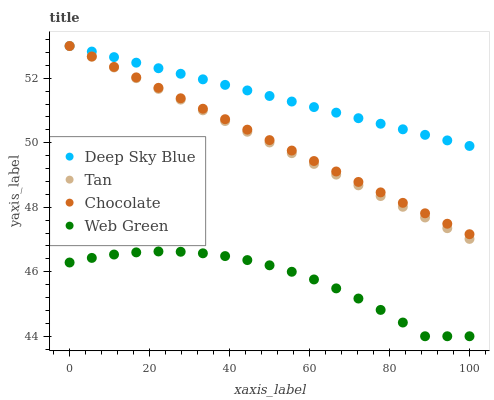Does Web Green have the minimum area under the curve?
Answer yes or no. Yes. Does Deep Sky Blue have the maximum area under the curve?
Answer yes or no. Yes. Does Deep Sky Blue have the minimum area under the curve?
Answer yes or no. No. Does Web Green have the maximum area under the curve?
Answer yes or no. No. Is Tan the smoothest?
Answer yes or no. Yes. Is Web Green the roughest?
Answer yes or no. Yes. Is Deep Sky Blue the smoothest?
Answer yes or no. No. Is Deep Sky Blue the roughest?
Answer yes or no. No. Does Web Green have the lowest value?
Answer yes or no. Yes. Does Deep Sky Blue have the lowest value?
Answer yes or no. No. Does Chocolate have the highest value?
Answer yes or no. Yes. Does Web Green have the highest value?
Answer yes or no. No. Is Web Green less than Tan?
Answer yes or no. Yes. Is Tan greater than Web Green?
Answer yes or no. Yes. Does Tan intersect Chocolate?
Answer yes or no. Yes. Is Tan less than Chocolate?
Answer yes or no. No. Is Tan greater than Chocolate?
Answer yes or no. No. Does Web Green intersect Tan?
Answer yes or no. No. 